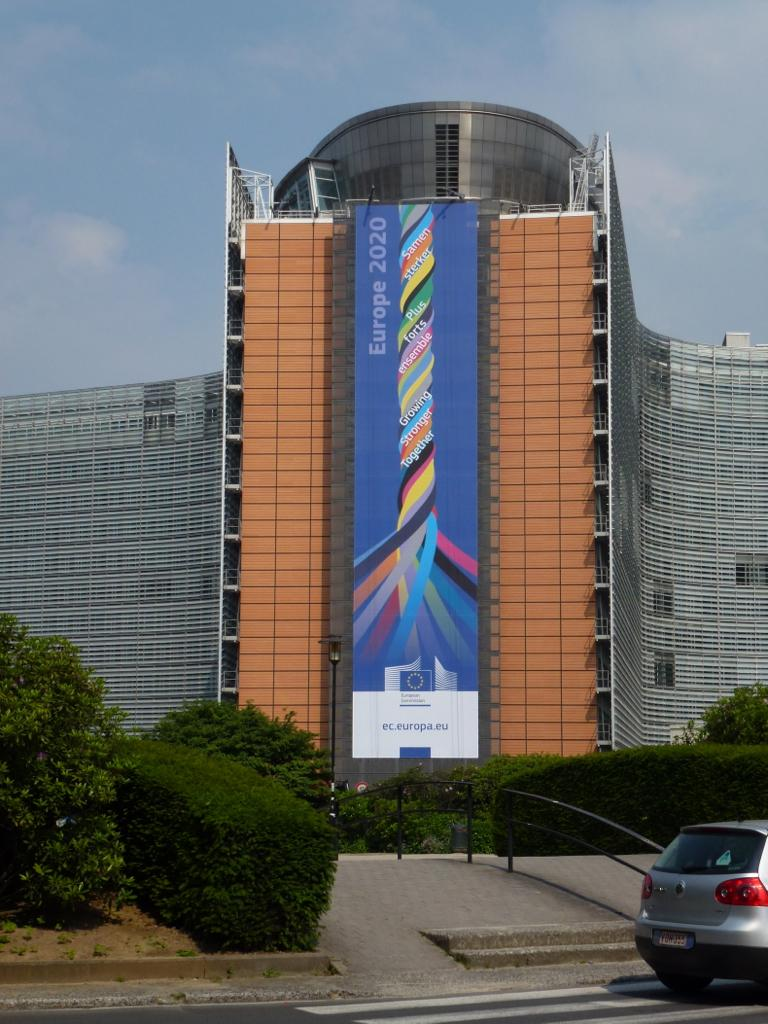What type of living organisms can be seen in the image? Plants are visible in the image. What architectural feature is present in the image? There are stairs and a handrail in the image. What is on the road in the image? There is a vehicle on the road in the image. What type of structure is in the image? There is a building in the image. What is visible in the sky in the image? The sky is visible in the image. What can be seen on the wall in the image? There is a poster with text and images in the image. Can you see the mouth of the cave in the image? There is no cave present in the image. What type of board is being used by the plants in the image? There are no boards present in the image, as it features plants, stairs, a handrail, a vehicle, a building, the sky, and a poster. 